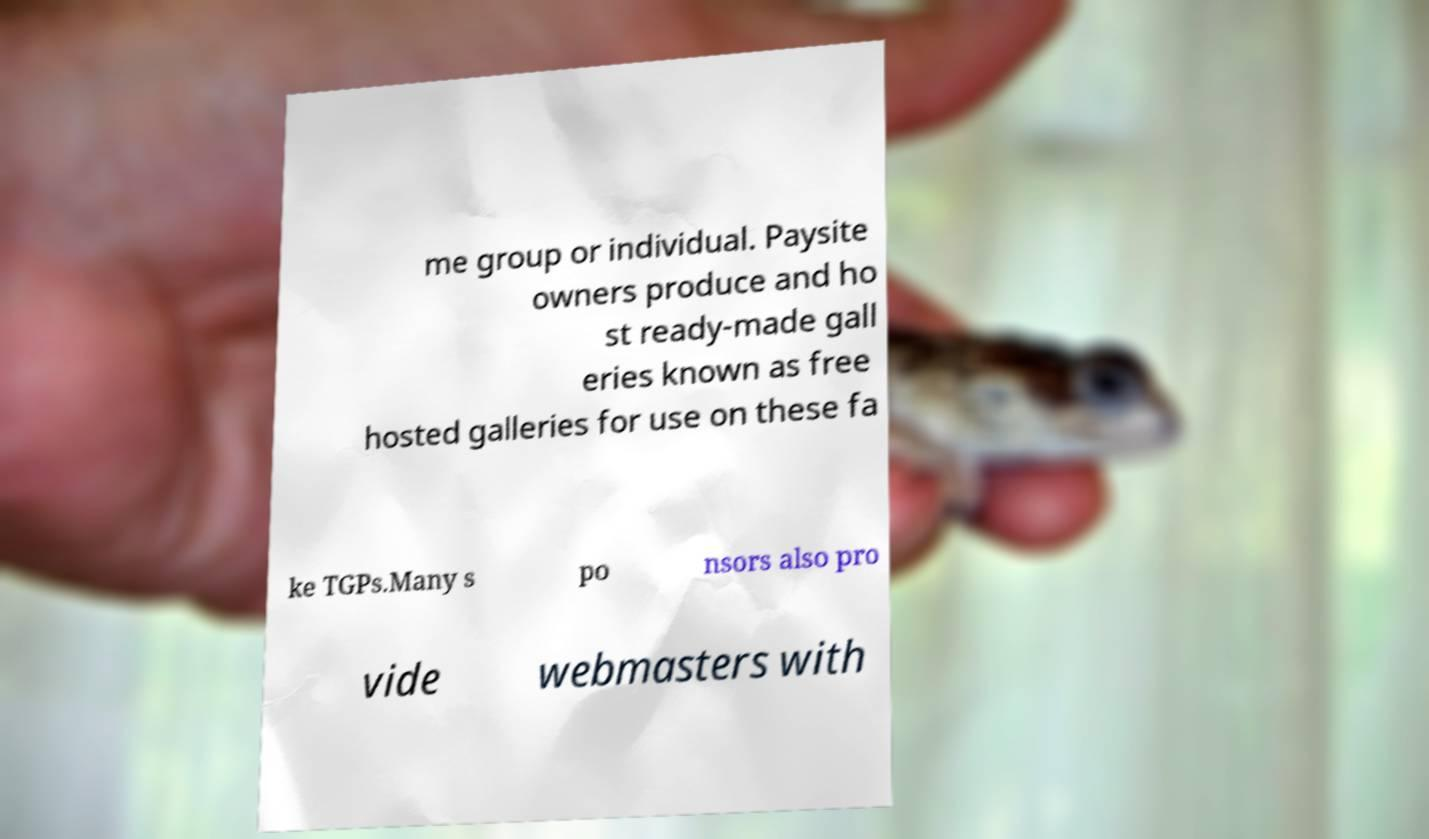Could you extract and type out the text from this image? me group or individual. Paysite owners produce and ho st ready-made gall eries known as free hosted galleries for use on these fa ke TGPs.Many s po nsors also pro vide webmasters with 